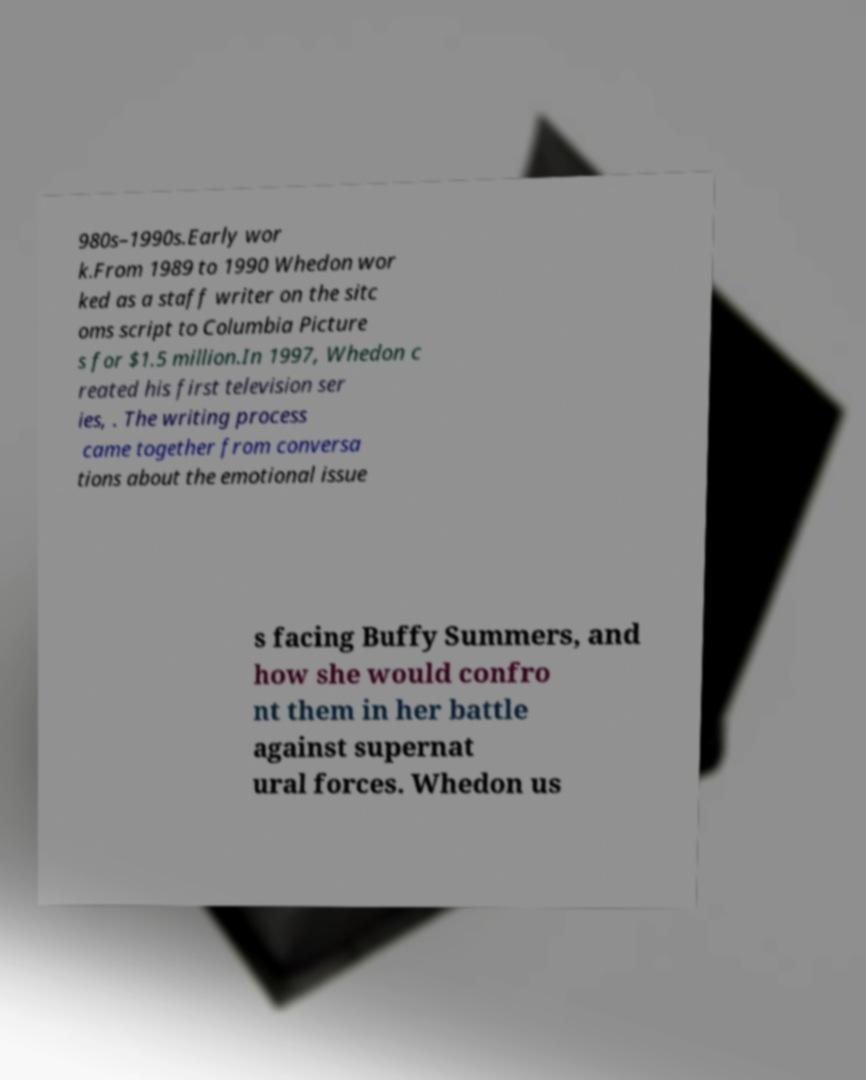Please read and relay the text visible in this image. What does it say? 980s–1990s.Early wor k.From 1989 to 1990 Whedon wor ked as a staff writer on the sitc oms script to Columbia Picture s for $1.5 million.In 1997, Whedon c reated his first television ser ies, . The writing process came together from conversa tions about the emotional issue s facing Buffy Summers, and how she would confro nt them in her battle against supernat ural forces. Whedon us 